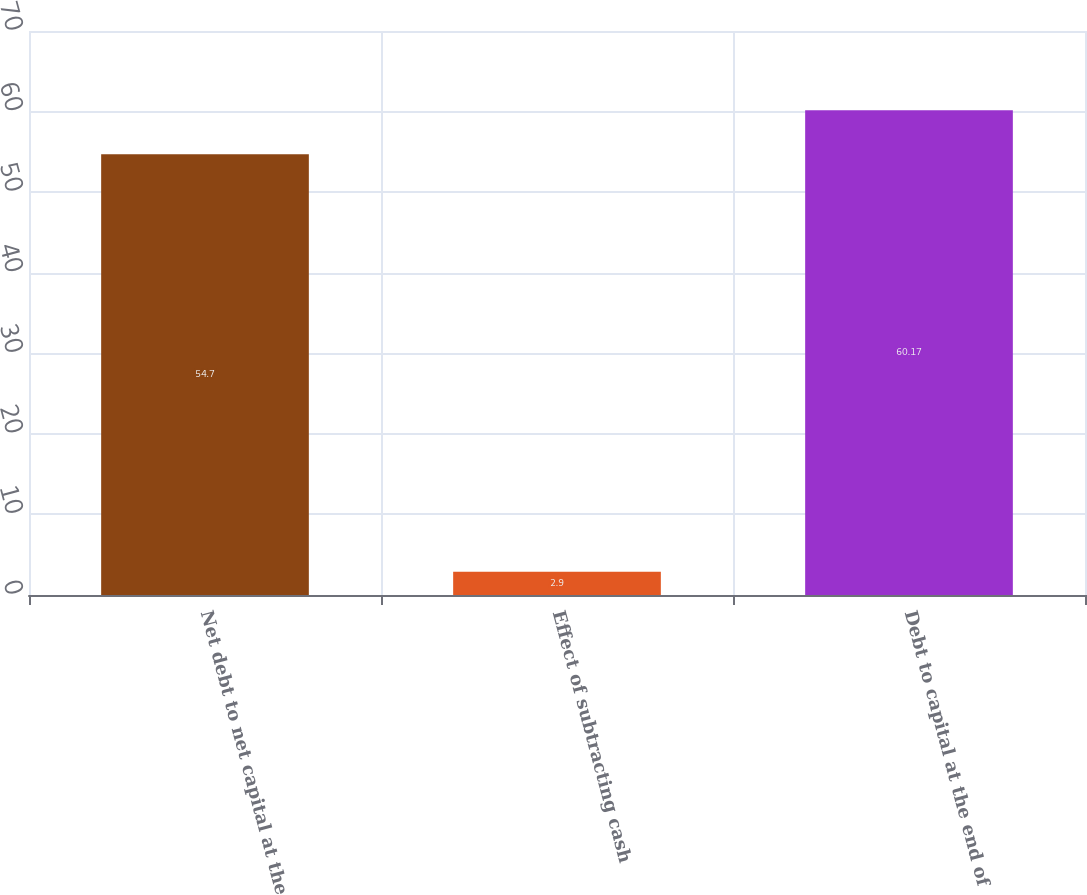Convert chart to OTSL. <chart><loc_0><loc_0><loc_500><loc_500><bar_chart><fcel>Net debt to net capital at the<fcel>Effect of subtracting cash<fcel>Debt to capital at the end of<nl><fcel>54.7<fcel>2.9<fcel>60.17<nl></chart> 